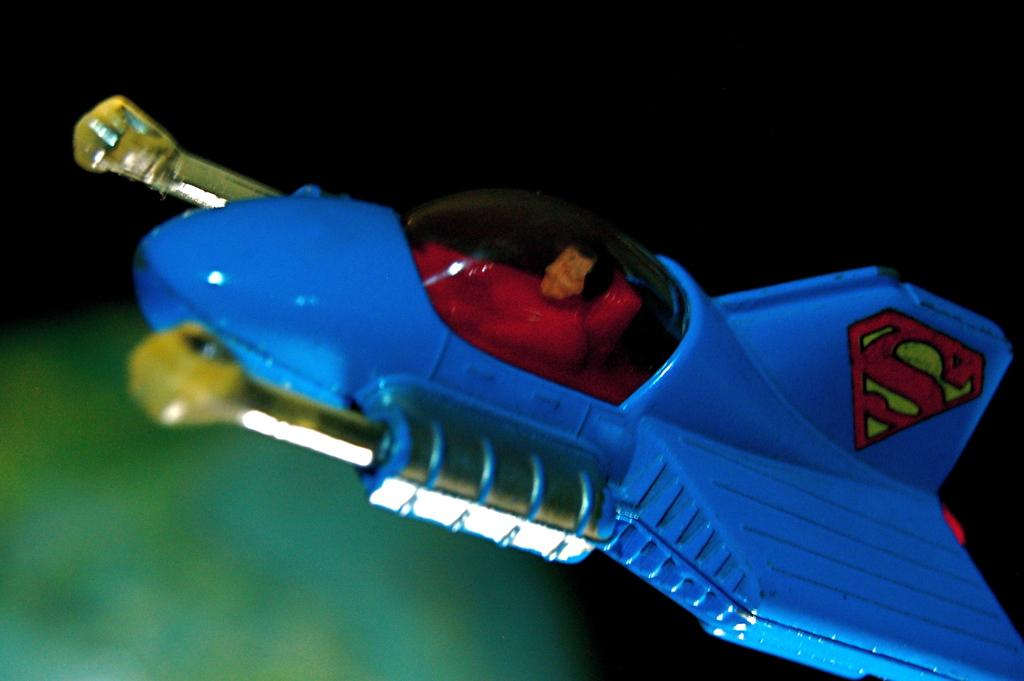Provide a one-sentence caption for the provided image. The toy jet plane has the Superman S on it's tail. 